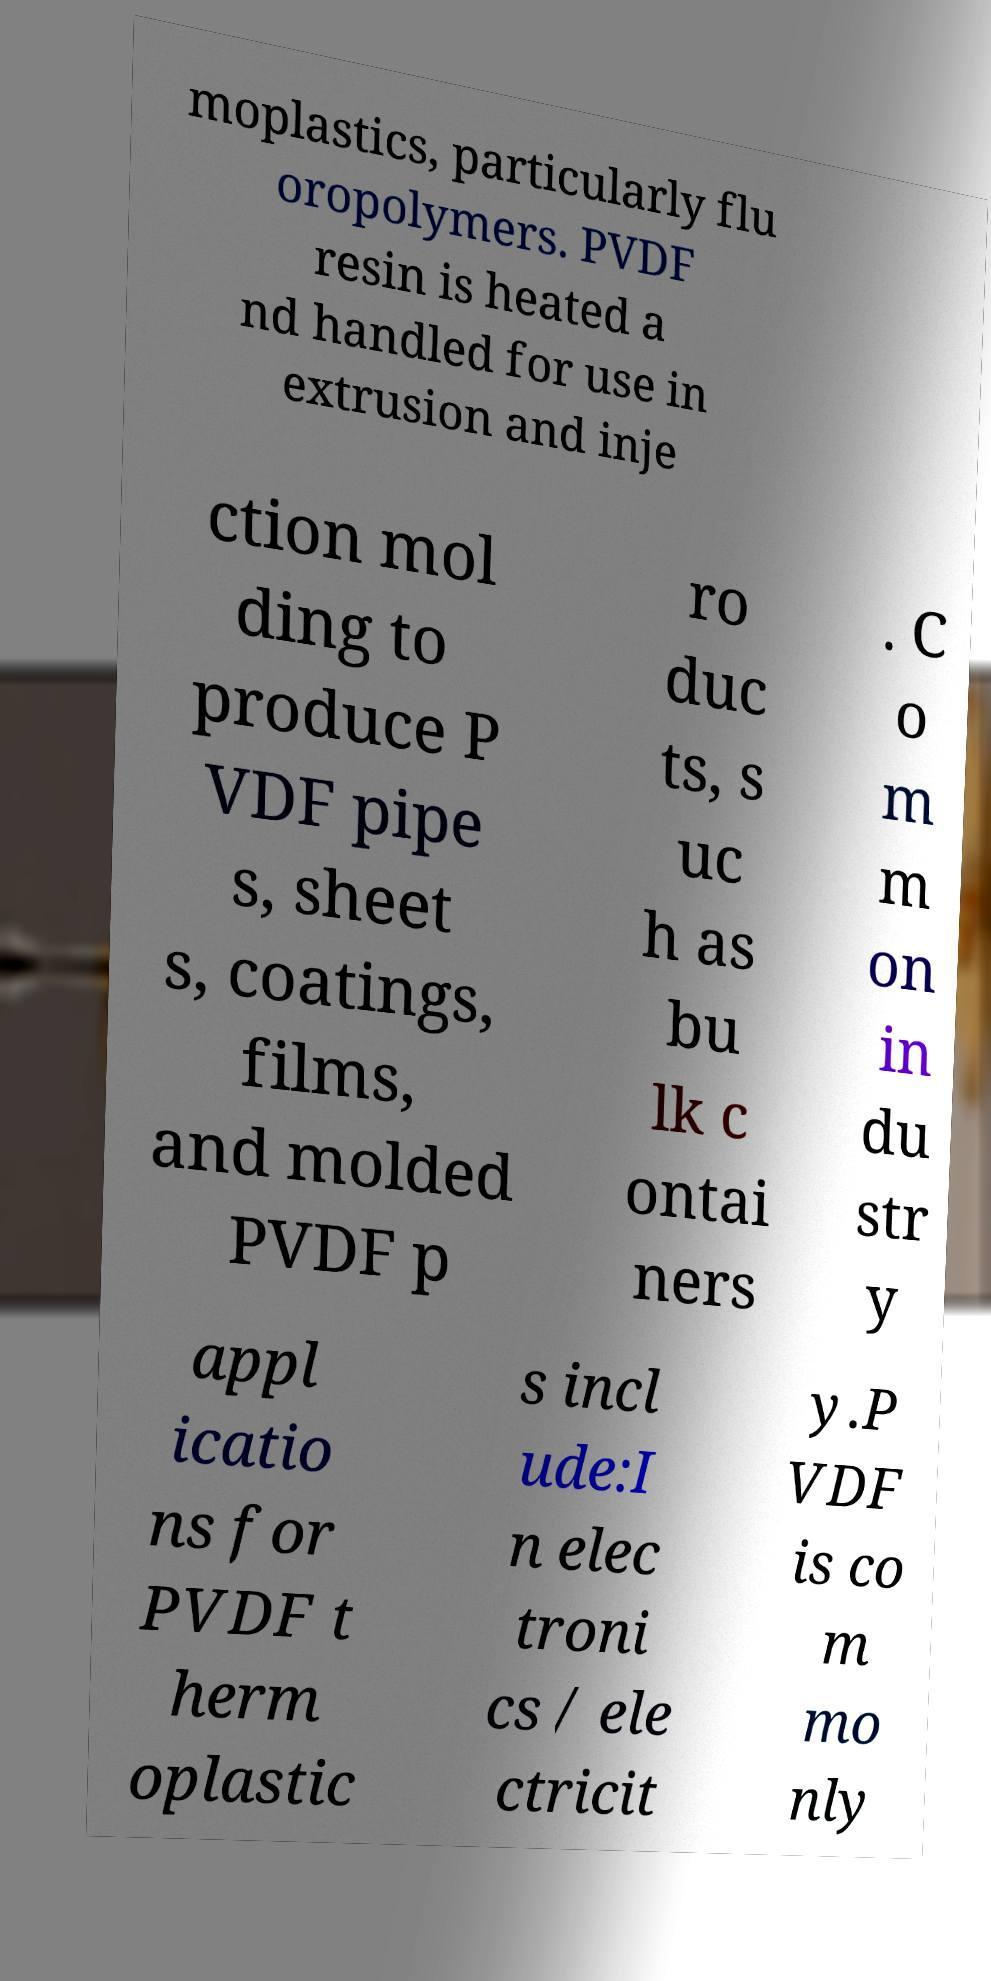Could you assist in decoding the text presented in this image and type it out clearly? moplastics, particularly flu oropolymers. PVDF resin is heated a nd handled for use in extrusion and inje ction mol ding to produce P VDF pipe s, sheet s, coatings, films, and molded PVDF p ro duc ts, s uc h as bu lk c ontai ners . C o m m on in du str y appl icatio ns for PVDF t herm oplastic s incl ude:I n elec troni cs / ele ctricit y.P VDF is co m mo nly 